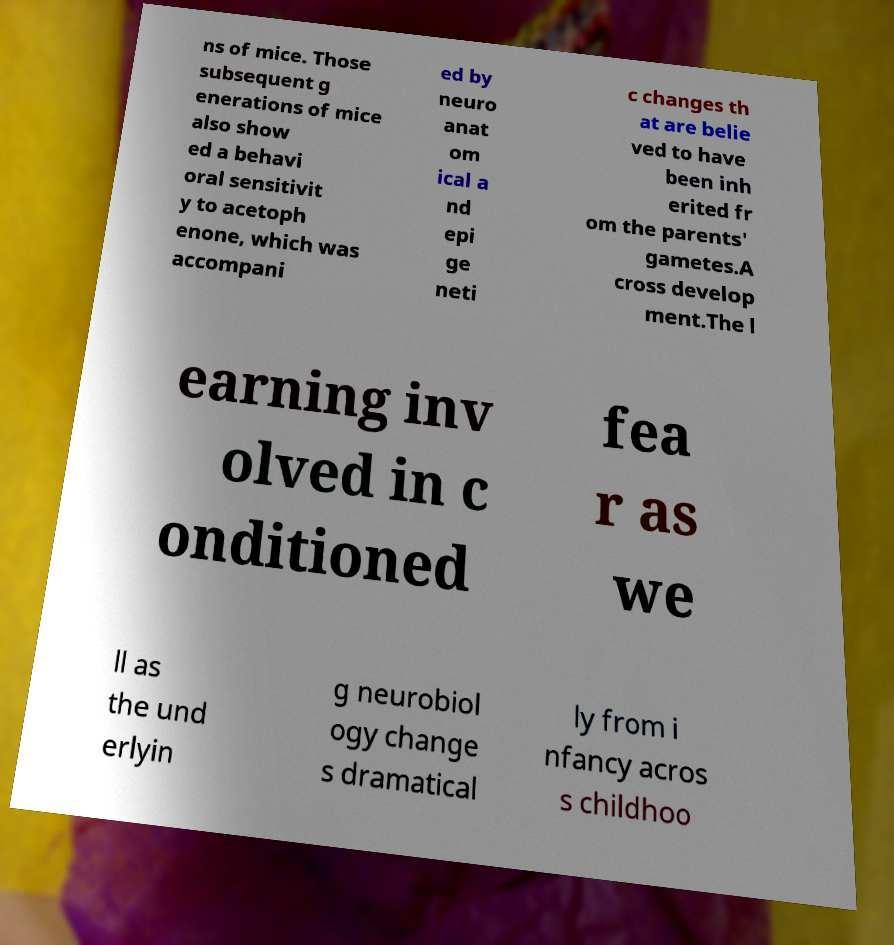There's text embedded in this image that I need extracted. Can you transcribe it verbatim? ns of mice. Those subsequent g enerations of mice also show ed a behavi oral sensitivit y to acetoph enone, which was accompani ed by neuro anat om ical a nd epi ge neti c changes th at are belie ved to have been inh erited fr om the parents' gametes.A cross develop ment.The l earning inv olved in c onditioned fea r as we ll as the und erlyin g neurobiol ogy change s dramatical ly from i nfancy acros s childhoo 